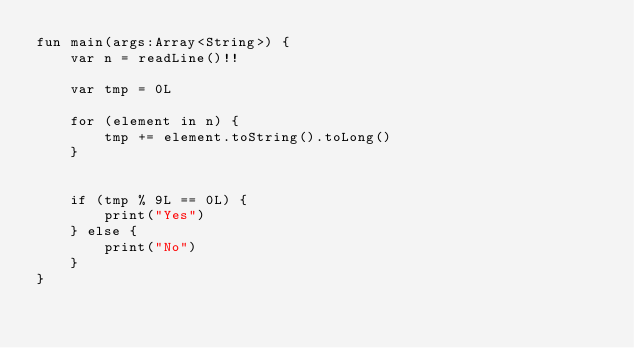<code> <loc_0><loc_0><loc_500><loc_500><_Kotlin_>fun main(args:Array<String>) {
    var n = readLine()!!

    var tmp = 0L

    for (element in n) {
        tmp += element.toString().toLong()
    }


    if (tmp % 9L == 0L) {
        print("Yes")
    } else {
        print("No")
    }
}</code> 